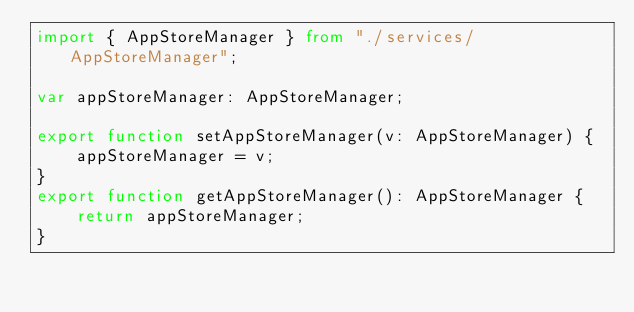<code> <loc_0><loc_0><loc_500><loc_500><_TypeScript_>import { AppStoreManager } from "./services/AppStoreManager";

var appStoreManager: AppStoreManager;

export function setAppStoreManager(v: AppStoreManager) {
    appStoreManager = v;    
}
export function getAppStoreManager(): AppStoreManager {
    return appStoreManager;
}
</code> 